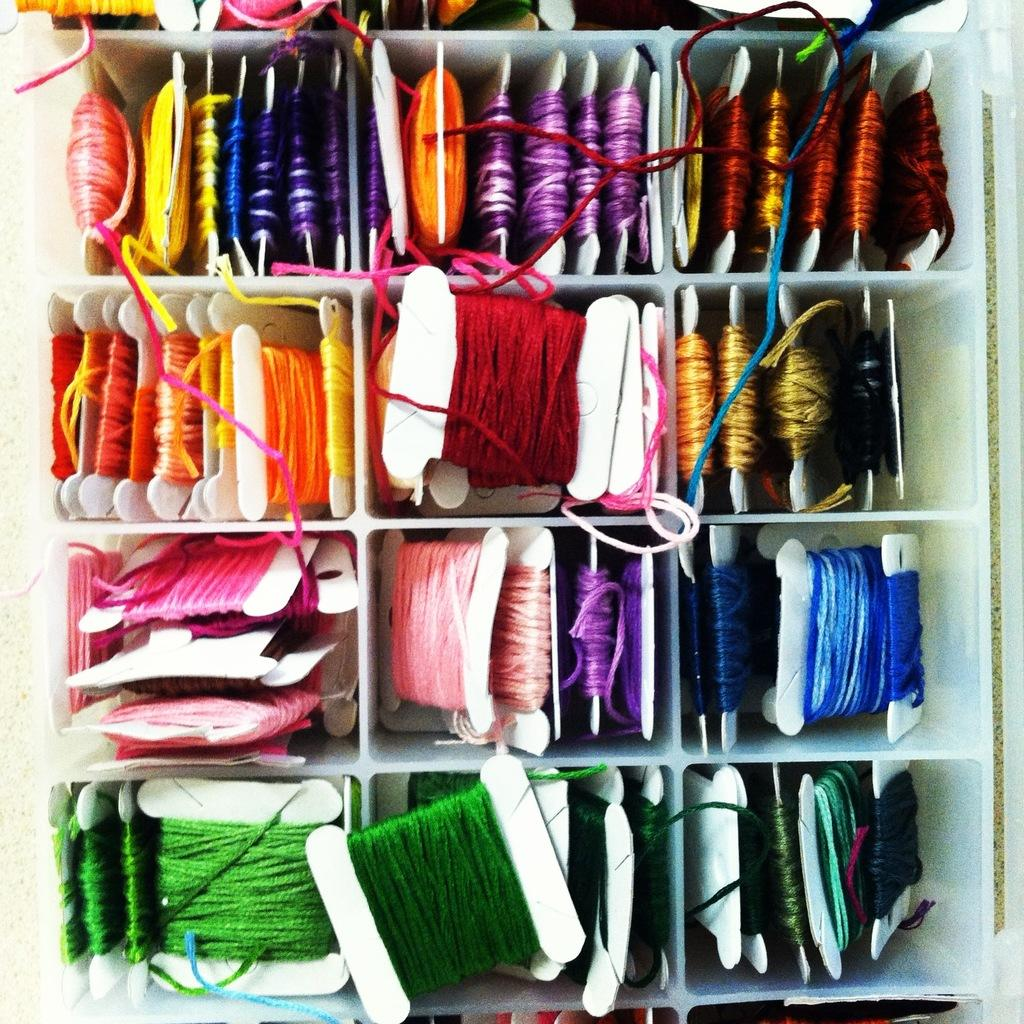What is present on the shelf in the image? There are threads on the shelf in the image. Can you describe the threads in more detail? Unfortunately, the provided facts do not offer more details about the threads. What might the threads be used for? The purpose of the threads is not specified in the given facts. How does the curtain affect the wealth of the people in the image? There is no curtain or mention of wealth in the image, so it is not possible to answer that question. 